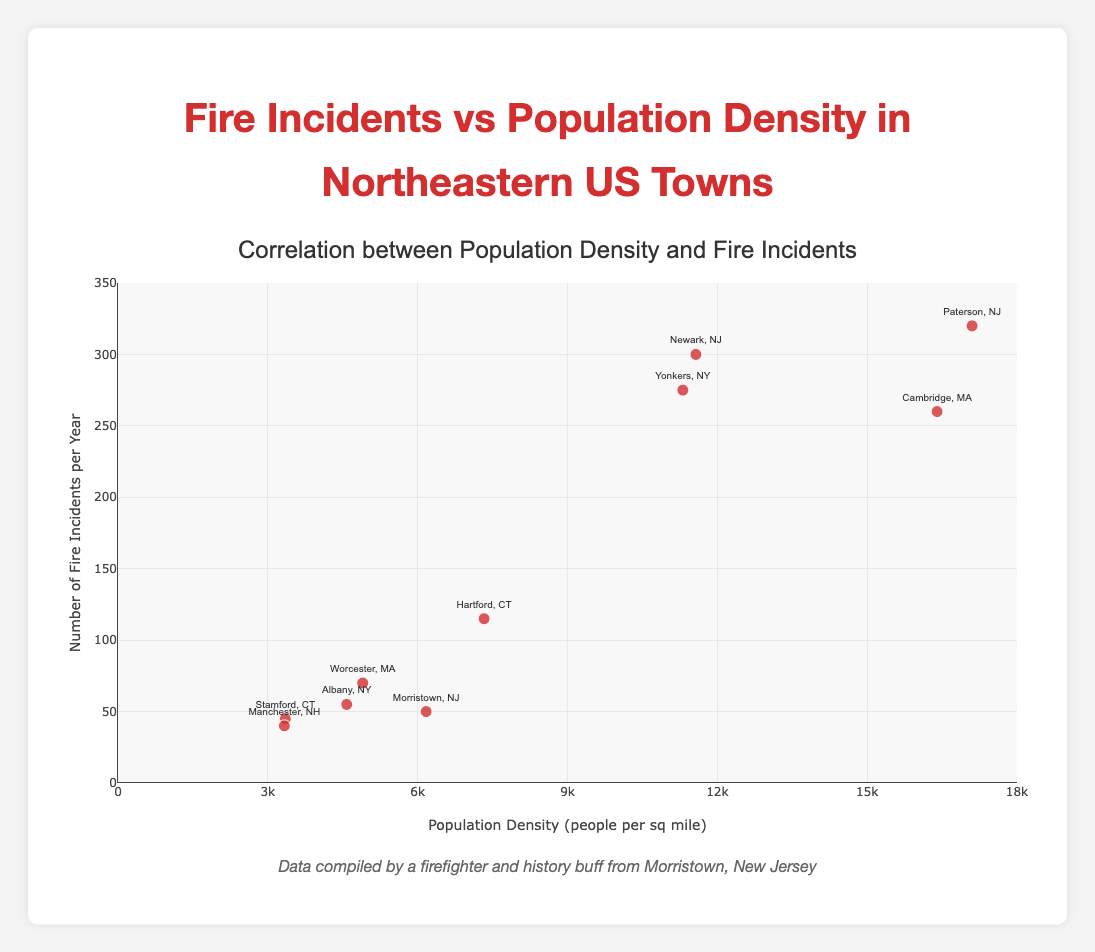What is the title of the scatter plot? The title can be found at the top of the chart and it provides context to the data being visualized.
Answer: Correlation between Population Density and Fire Incidents How many data points are plotted on the scatter plot? Count the number of markers on the scatter plot. Each marker represents a data point.
Answer: 10 What is the range of the x-axis? The x-axis represents Population Density and its range can be determined by looking at the labels and boundaries on the x-axis.
Answer: 0 to 18000 Which town has the highest number of fire incidents? Identify the marker with the highest y-axis value by referring to the hover text or the position of the marker on the scatter plot.
Answer: Paterson, NJ How many towns have a population density greater than 10000 people per square mile? Look at the x-axis values of each marker and count how many have values greater than 10000.
Answer: 4 Which has a higher population density, Albany, NY or Worcester, MA? Compare the x-axis values of the markers for Albany, NY and Worcester, MA.
Answer: Worcester, MA What is the population density range for towns with fewer than 100 fire incidents? Identify the markers for towns with fewer than 100 fire incidents and note their x-axis values to find the range.
Answer: 3330 to 7330 Calculate the average number of fire incidents for towns with a population density greater than 10000. Identify the markers for towns with a population density greater than 10000, sum their y-axis values, and then divide by the number of such towns.
Answer: (300 + 275 + 260 + 320) / 4 = 1130 / 4 = 282.5 Is there a positive correlation between population density and fire incidents? Observe the overall trend in the scatter plot: if fire incidents tend to increase with higher population density, the correlation is positive.
Answer: Yes Which town lies closest to the origin of the plot (0,0)? Identify the marker that is nearest to the lower left corner of the plot by looking at both x-axis (Population Density) and y-axis (Fire Incidents) values.
Answer: Manchester, NH 